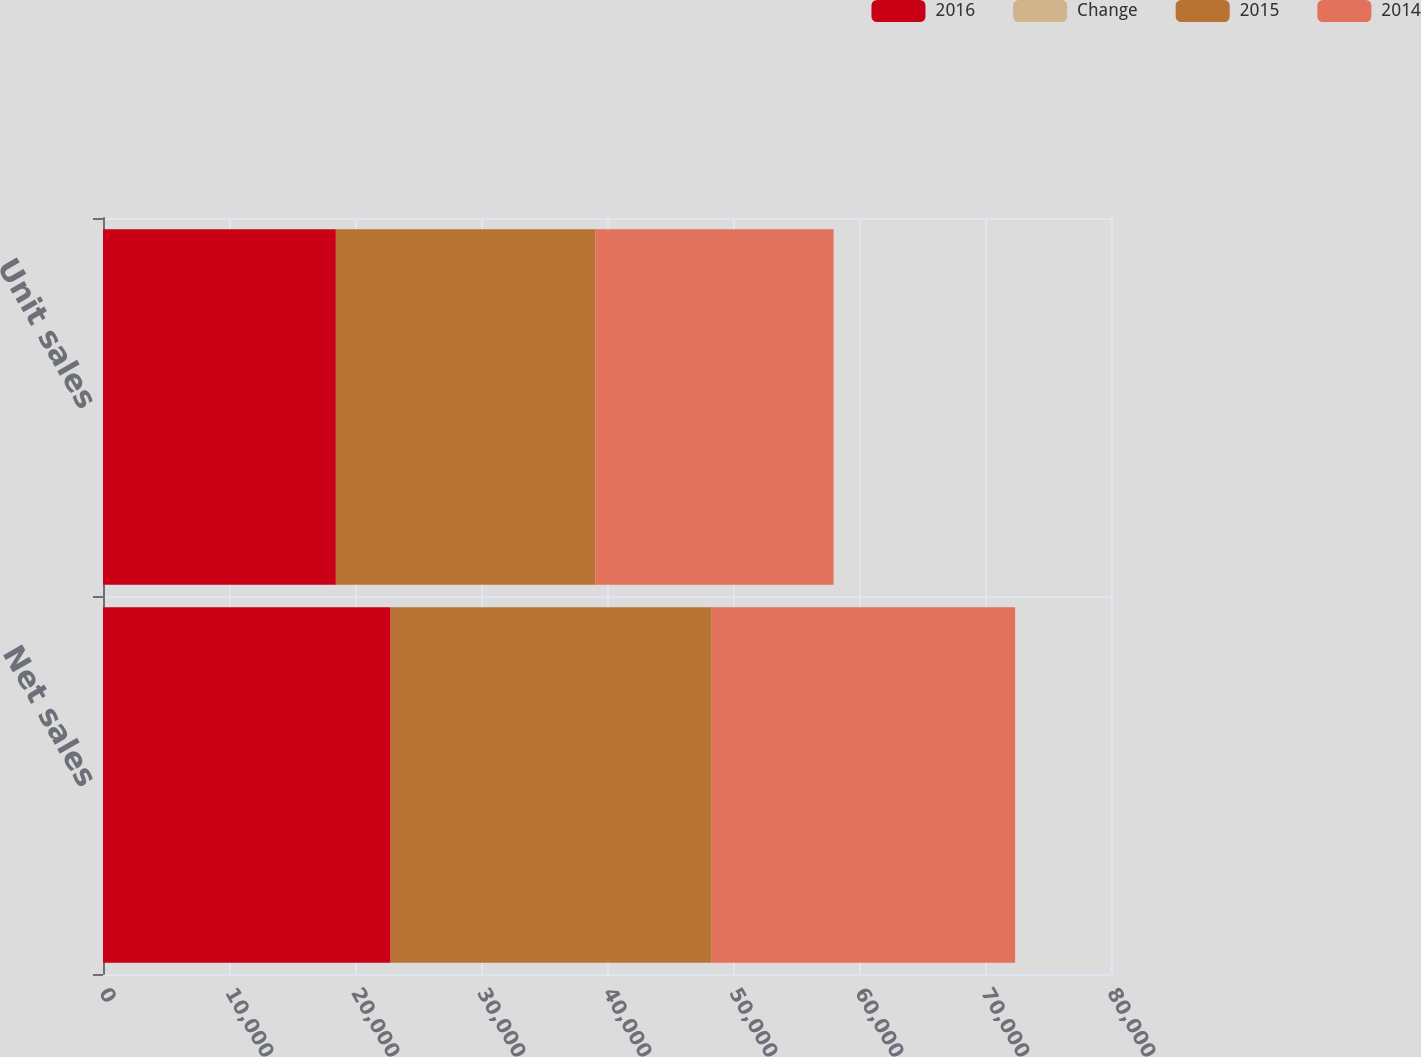Convert chart. <chart><loc_0><loc_0><loc_500><loc_500><stacked_bar_chart><ecel><fcel>Net sales<fcel>Unit sales<nl><fcel>2016<fcel>22831<fcel>18484<nl><fcel>Change<fcel>10<fcel>10<nl><fcel>2015<fcel>25471<fcel>20587<nl><fcel>2014<fcel>24079<fcel>18906<nl></chart> 